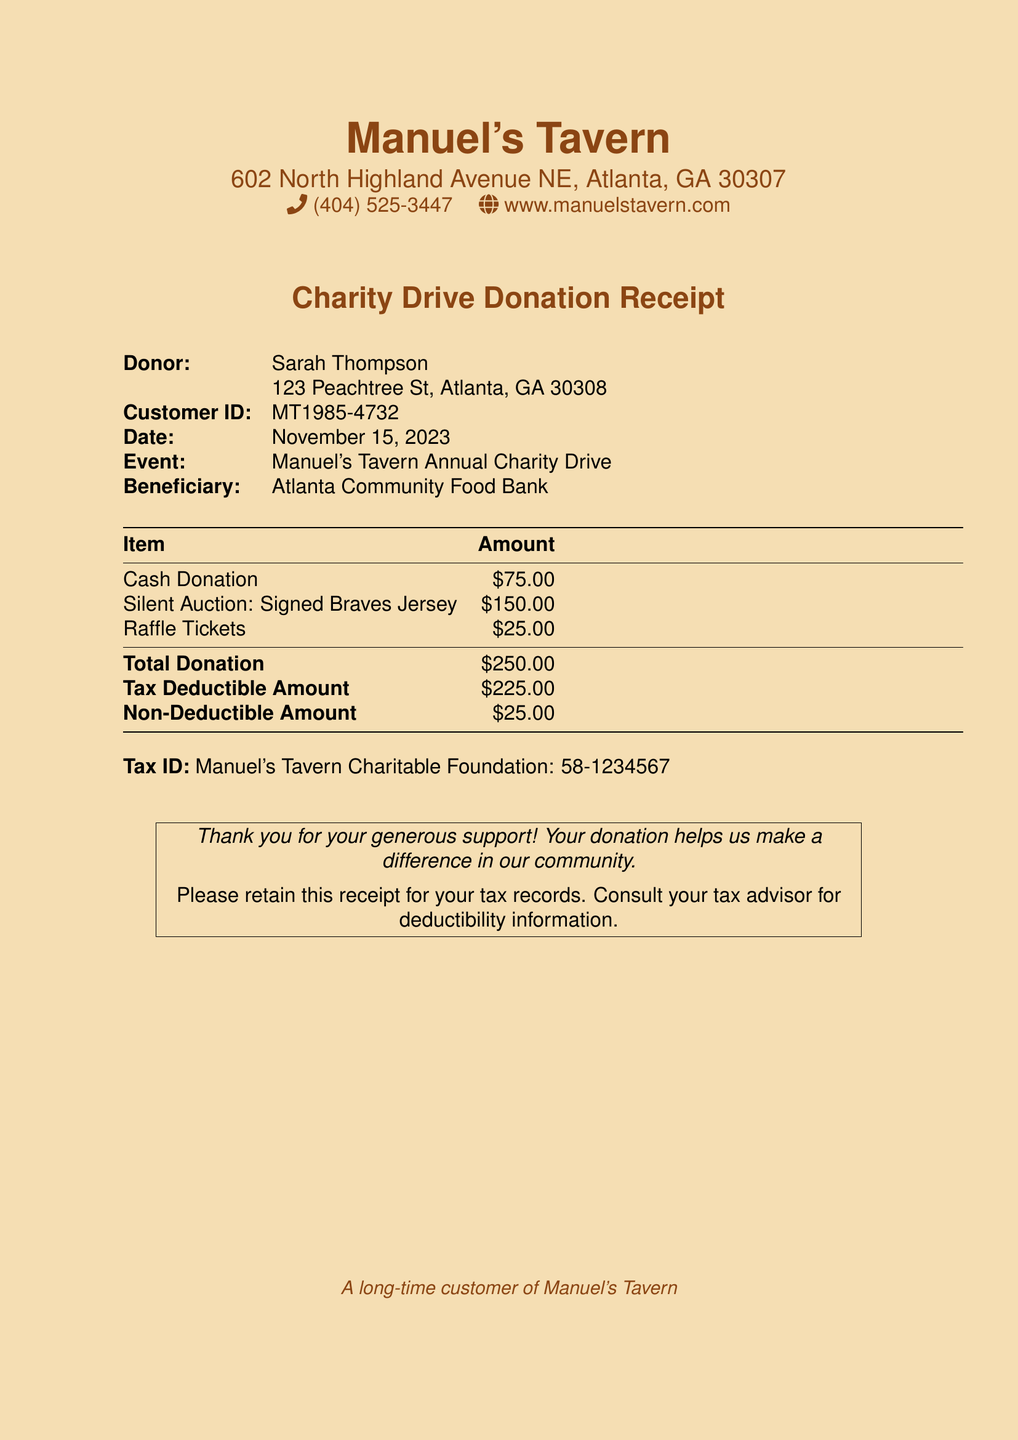what is the date of the donation receipt? The date of the donation receipt is clearly stated in the document as November 15, 2023.
Answer: November 15, 2023 who is the donor? The donor’s name is specified at the top of the document as Sarah Thompson.
Answer: Sarah Thompson what is the total donation amount? The total donation amount is listed in the document as the final line in the donation summary, which sums up all contributions.
Answer: $250.00 what portion of the donation is tax deductible? The document outlines the tax-deductible amount separately, which indicates how much can be claimed for tax purposes.
Answer: $225.00 what item has the highest donation value? The highest individual donation value comes from the silent auction for a signed Braves jersey.
Answer: Signed Braves Jersey what is the non-deductible amount from the total donation? The document specifies a portion of the total donation that is not deductible for tax purposes.
Answer: $25.00 which organization benefits from the charity drive? The beneficiary of the annual charity drive is listed in the document, providing insight into where the donations will support.
Answer: Atlanta Community Food Bank what is the tax ID number of Manuel's Tavern Charitable Foundation? The tax ID number is explicitly provided in the document for identification and record-keeping purposes.
Answer: 58-1234567 what event is this donation associated with? The specific fundraising event for which the donation was made is indicated in the document title.
Answer: Manuel's Tavern Annual Charity Drive 